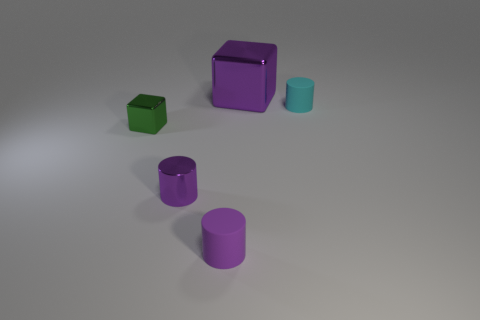Are there fewer shiny cylinders behind the small cyan object than green things?
Offer a very short reply. Yes. Is there a yellow matte cube that has the same size as the cyan matte cylinder?
Keep it short and to the point. No. There is a big metallic object; does it have the same color as the tiny rubber object that is on the left side of the cyan matte cylinder?
Your answer should be compact. Yes. What number of tiny things are to the right of the purple object behind the cyan thing?
Make the answer very short. 1. The rubber object right of the purple metal thing behind the tiny green shiny block is what color?
Give a very brief answer. Cyan. There is a purple object that is both behind the small purple matte cylinder and in front of the tiny cyan cylinder; what is it made of?
Offer a very short reply. Metal. Is there another tiny green shiny object of the same shape as the green object?
Provide a succinct answer. No. There is a tiny object that is in front of the purple shiny cylinder; does it have the same shape as the cyan object?
Provide a short and direct response. Yes. What number of metal objects are in front of the green thing and on the left side of the tiny purple shiny thing?
Ensure brevity in your answer.  0. What is the shape of the rubber object on the left side of the small cyan matte cylinder?
Your answer should be very brief. Cylinder. 